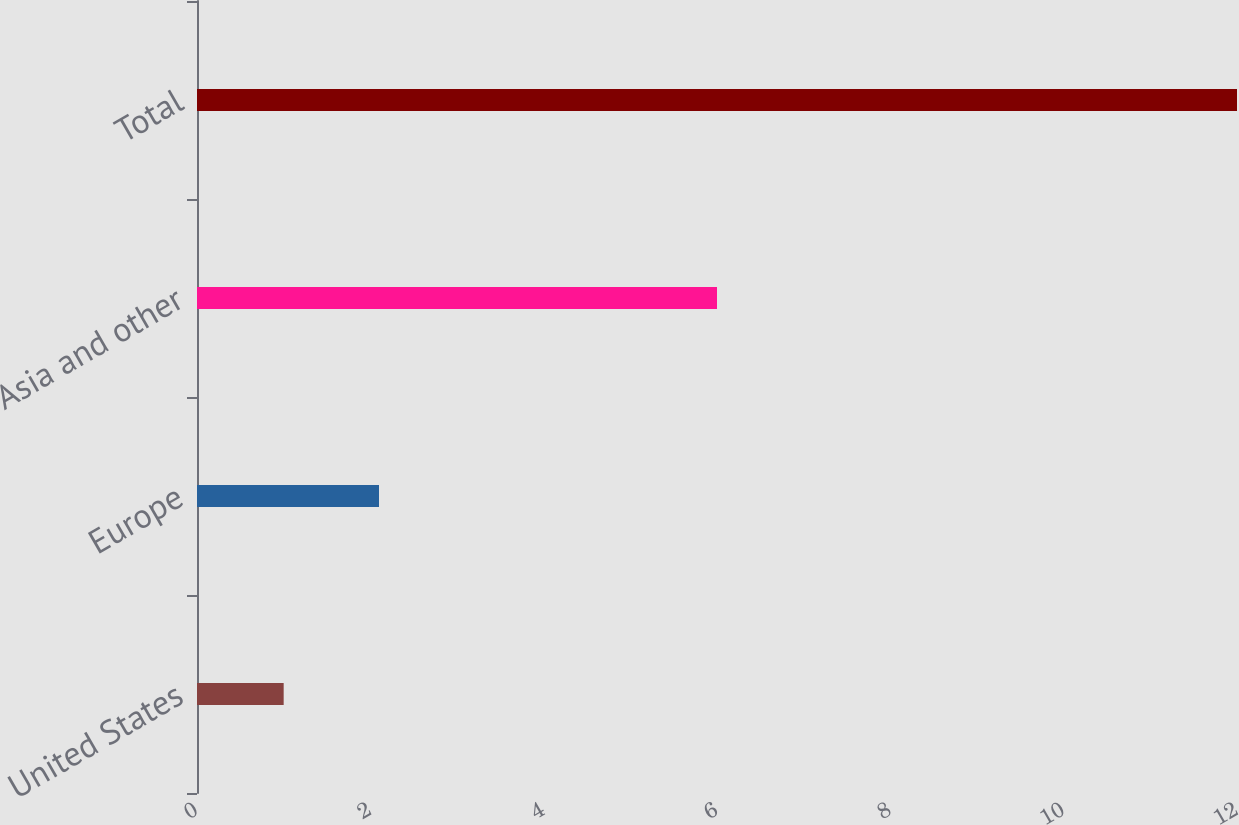Convert chart to OTSL. <chart><loc_0><loc_0><loc_500><loc_500><bar_chart><fcel>United States<fcel>Europe<fcel>Asia and other<fcel>Total<nl><fcel>1<fcel>2.1<fcel>6<fcel>12<nl></chart> 